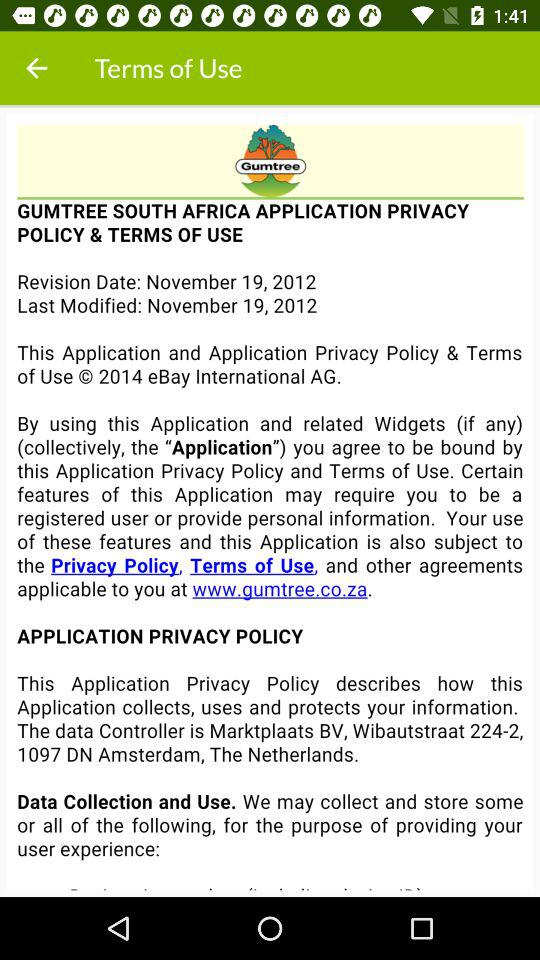What is the revision date of an application? The revision date is November 19, 2012. 